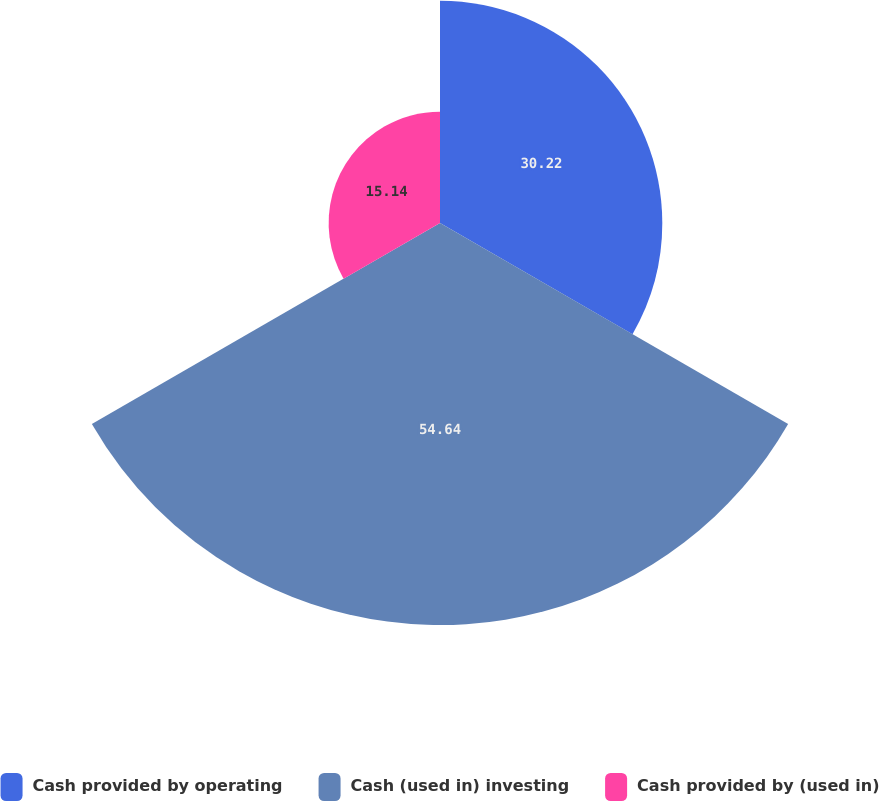Convert chart to OTSL. <chart><loc_0><loc_0><loc_500><loc_500><pie_chart><fcel>Cash provided by operating<fcel>Cash (used in) investing<fcel>Cash provided by (used in)<nl><fcel>30.22%<fcel>54.65%<fcel>15.14%<nl></chart> 